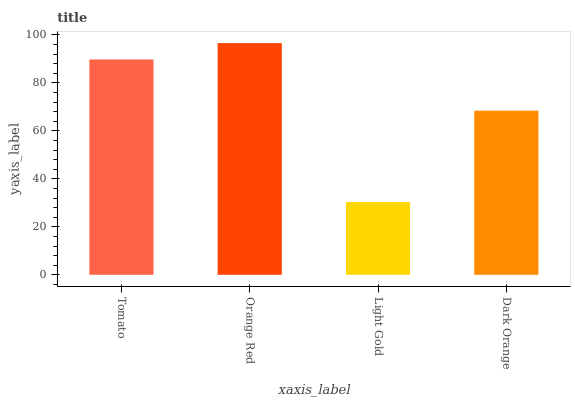Is Orange Red the minimum?
Answer yes or no. No. Is Light Gold the maximum?
Answer yes or no. No. Is Orange Red greater than Light Gold?
Answer yes or no. Yes. Is Light Gold less than Orange Red?
Answer yes or no. Yes. Is Light Gold greater than Orange Red?
Answer yes or no. No. Is Orange Red less than Light Gold?
Answer yes or no. No. Is Tomato the high median?
Answer yes or no. Yes. Is Dark Orange the low median?
Answer yes or no. Yes. Is Orange Red the high median?
Answer yes or no. No. Is Orange Red the low median?
Answer yes or no. No. 